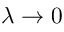Convert formula to latex. <formula><loc_0><loc_0><loc_500><loc_500>\lambda \to 0</formula> 